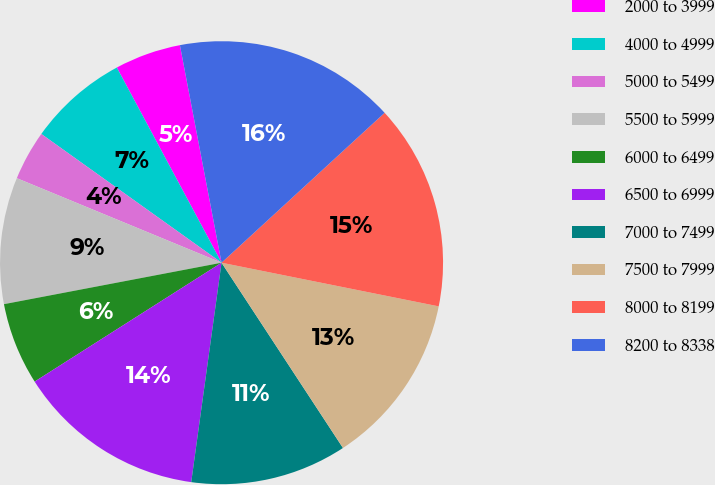Convert chart. <chart><loc_0><loc_0><loc_500><loc_500><pie_chart><fcel>2000 to 3999<fcel>4000 to 4999<fcel>5000 to 5499<fcel>5500 to 5999<fcel>6000 to 6499<fcel>6500 to 6999<fcel>7000 to 7499<fcel>7500 to 7999<fcel>8000 to 8199<fcel>8200 to 8338<nl><fcel>4.83%<fcel>7.29%<fcel>3.64%<fcel>9.23%<fcel>6.02%<fcel>13.8%<fcel>11.42%<fcel>12.61%<fcel>14.99%<fcel>16.18%<nl></chart> 